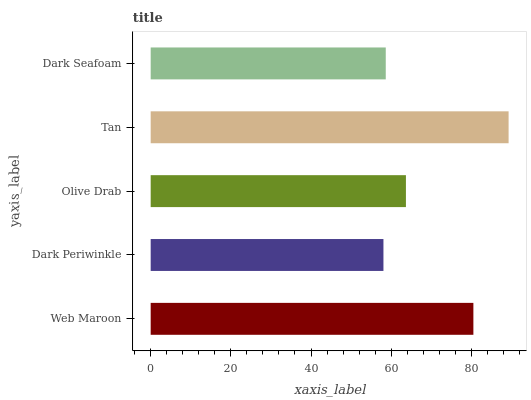Is Dark Periwinkle the minimum?
Answer yes or no. Yes. Is Tan the maximum?
Answer yes or no. Yes. Is Olive Drab the minimum?
Answer yes or no. No. Is Olive Drab the maximum?
Answer yes or no. No. Is Olive Drab greater than Dark Periwinkle?
Answer yes or no. Yes. Is Dark Periwinkle less than Olive Drab?
Answer yes or no. Yes. Is Dark Periwinkle greater than Olive Drab?
Answer yes or no. No. Is Olive Drab less than Dark Periwinkle?
Answer yes or no. No. Is Olive Drab the high median?
Answer yes or no. Yes. Is Olive Drab the low median?
Answer yes or no. Yes. Is Tan the high median?
Answer yes or no. No. Is Web Maroon the low median?
Answer yes or no. No. 